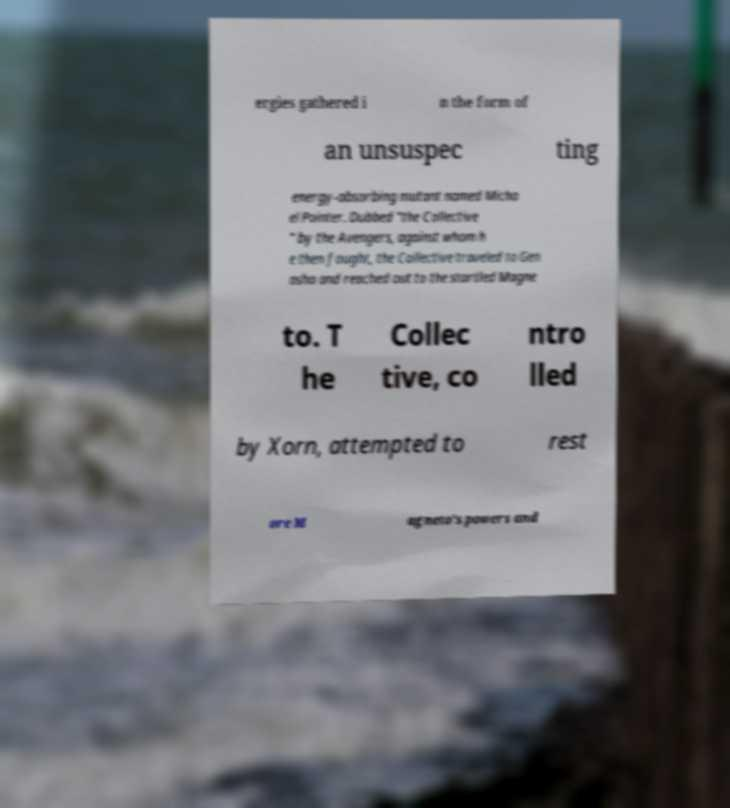For documentation purposes, I need the text within this image transcribed. Could you provide that? ergies gathered i n the form of an unsuspec ting energy-absorbing mutant named Micha el Pointer. Dubbed "the Collective " by the Avengers, against whom h e then fought, the Collective traveled to Gen osha and reached out to the startled Magne to. T he Collec tive, co ntro lled by Xorn, attempted to rest ore M agneto's powers and 